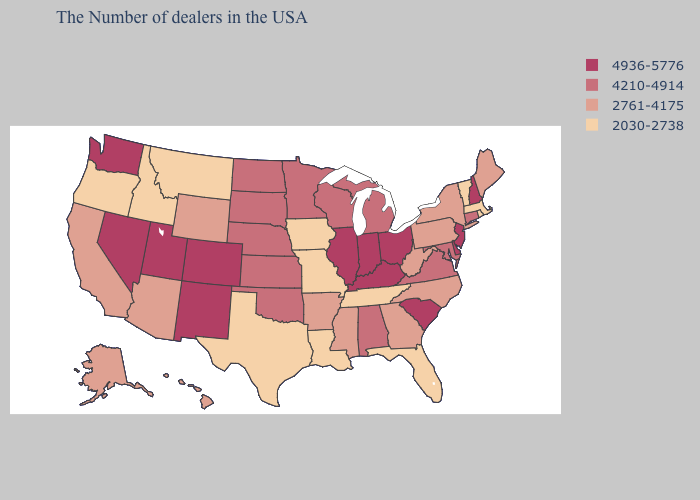What is the value of Alaska?
Keep it brief. 2761-4175. Name the states that have a value in the range 4936-5776?
Answer briefly. New Hampshire, New Jersey, Delaware, South Carolina, Ohio, Kentucky, Indiana, Illinois, Colorado, New Mexico, Utah, Nevada, Washington. What is the value of Colorado?
Write a very short answer. 4936-5776. What is the lowest value in the USA?
Be succinct. 2030-2738. Is the legend a continuous bar?
Answer briefly. No. Does Minnesota have a higher value than Washington?
Give a very brief answer. No. Name the states that have a value in the range 2030-2738?
Answer briefly. Massachusetts, Rhode Island, Vermont, Florida, Tennessee, Louisiana, Missouri, Iowa, Texas, Montana, Idaho, Oregon. Name the states that have a value in the range 2030-2738?
Give a very brief answer. Massachusetts, Rhode Island, Vermont, Florida, Tennessee, Louisiana, Missouri, Iowa, Texas, Montana, Idaho, Oregon. Name the states that have a value in the range 2030-2738?
Answer briefly. Massachusetts, Rhode Island, Vermont, Florida, Tennessee, Louisiana, Missouri, Iowa, Texas, Montana, Idaho, Oregon. Among the states that border Utah , does Wyoming have the lowest value?
Quick response, please. No. What is the value of Indiana?
Short answer required. 4936-5776. Does Montana have the lowest value in the USA?
Keep it brief. Yes. Name the states that have a value in the range 2761-4175?
Be succinct. Maine, New York, Pennsylvania, North Carolina, West Virginia, Georgia, Mississippi, Arkansas, Wyoming, Arizona, California, Alaska, Hawaii. Does Oklahoma have the lowest value in the USA?
Answer briefly. No. Does Wyoming have the lowest value in the West?
Quick response, please. No. 